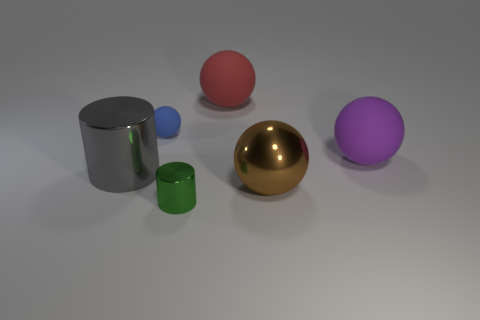Are there an equal number of red matte things that are in front of the tiny blue rubber thing and yellow metallic balls?
Your answer should be very brief. Yes. What number of rubber things are in front of the small blue object and left of the big purple object?
Provide a short and direct response. 0. There is a green cylinder that is made of the same material as the large brown object; what is its size?
Give a very brief answer. Small. How many large metallic things are the same shape as the tiny green metallic object?
Provide a succinct answer. 1. Is the number of rubber things that are on the right side of the brown shiny thing greater than the number of big blue shiny cubes?
Provide a succinct answer. Yes. What is the shape of the large thing that is to the right of the large gray shiny thing and left of the metal sphere?
Make the answer very short. Sphere. Is the size of the gray shiny cylinder the same as the green thing?
Make the answer very short. No. What number of tiny matte objects are in front of the purple rubber sphere?
Give a very brief answer. 0. Are there an equal number of large gray metallic cylinders that are right of the big brown thing and green metallic things that are to the right of the big purple object?
Your answer should be very brief. Yes. There is a large metal object that is on the right side of the gray cylinder; is its shape the same as the large purple matte thing?
Make the answer very short. Yes. 